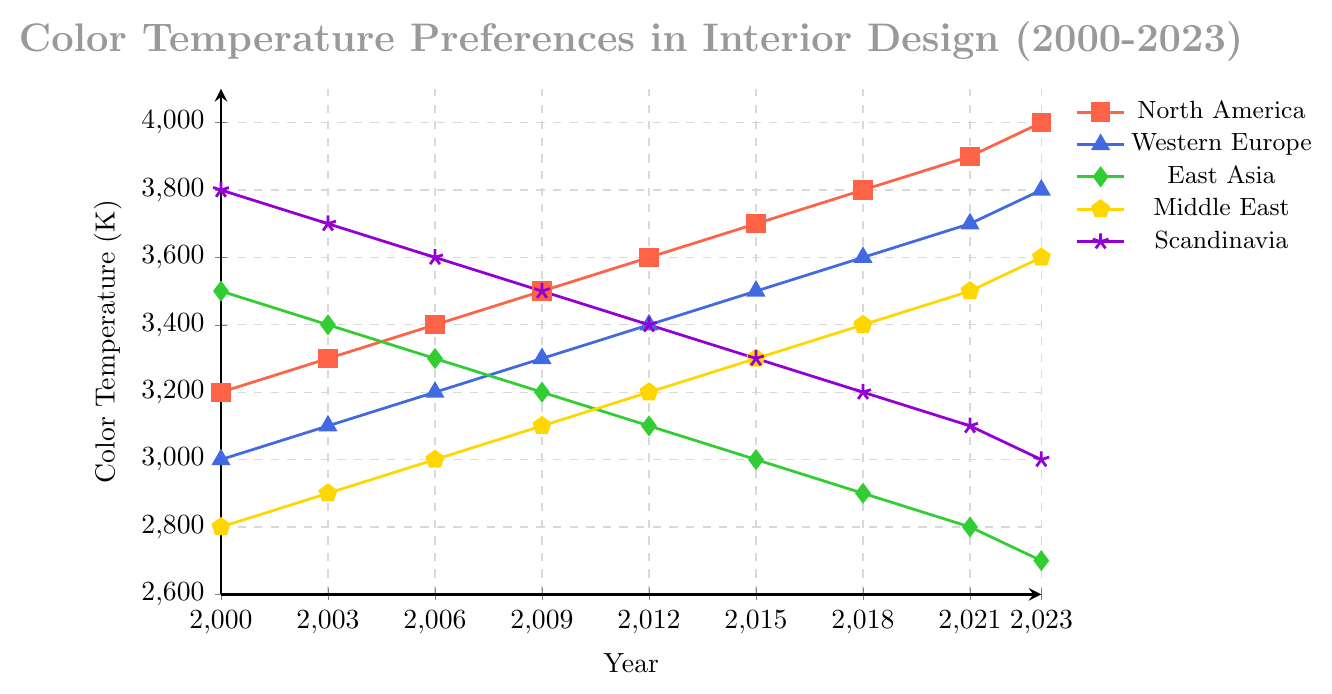what is the color temperature range covered by all regions in 2023? The lowest temperature in 2023 is from East Asia at 2700K, and the highest is from North America at 4000K. Hence, the range is from 2700K to 4000K.
Answer: 2700K to 4000K Which region had the highest color temperature preference in 2000, and what was the value? By looking at the data from 2000, Scandinavia had the highest color temperature preference at 3800K.
Answer: Scandinavia, 3800K What is the average color temperature preference for Middle East over all years shown? Sum the temperatures for Middle East (2800+2900+3000+3100+3200+3300+3400+3500+3600) and divide by 9. The total is 28800, so the average is 28800/9 = 3200K.
Answer: 3200K How has the color temperature preference for East Asia changed from 2000 to 2023? The temperature preference for East Asia has decreased from 3500K in 2000 to 2700K in 2023.
Answer: Decreased Which region saw the most consistent year-by-year increase in color temperature preferences from 2000 to 2023? North America shows a consistent increase every three years, from 3200K in 2000 to 4000K in 2023.
Answer: North America Visually, which region uses a green color line in the plot? In the plot, East Asia is represented by a green color line.
Answer: East Asia In 2006, which region had a lower color temperature preference, Western Europe or Middle East? In 2006, Middle East had a lower color temperature of 3000K compared to Western Europe’s 3200K.
Answer: Middle East What is the trend in color temperature preference in Scandinavia from 2012 to 2023? The color temperature preference in Scandinavia has decreased from 3400K in 2012 to 3000K in 2023.
Answer: Decreased Looking at years 2009 and 2012, which region experienced a larger increase in color temperature preference, Middle East or North America? Middle East increased from 3100K in 2009 to 3200K in 2012 (100K increase), while North America increased from 3500K to 3600K (also a 100K increase). Both experienced the same increase.
Answer: Same increase 